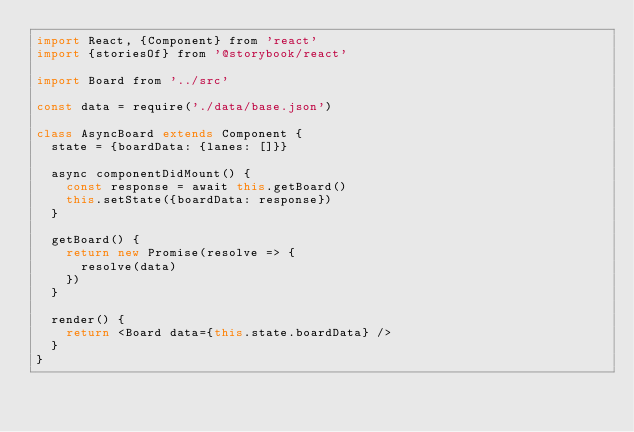<code> <loc_0><loc_0><loc_500><loc_500><_JavaScript_>import React, {Component} from 'react'
import {storiesOf} from '@storybook/react'

import Board from '../src'

const data = require('./data/base.json')

class AsyncBoard extends Component {
  state = {boardData: {lanes: []}}

  async componentDidMount() {
    const response = await this.getBoard()
    this.setState({boardData: response})
  }

  getBoard() {
    return new Promise(resolve => {
      resolve(data)
    })
  }

  render() {
    return <Board data={this.state.boardData} />
  }
}
</code> 